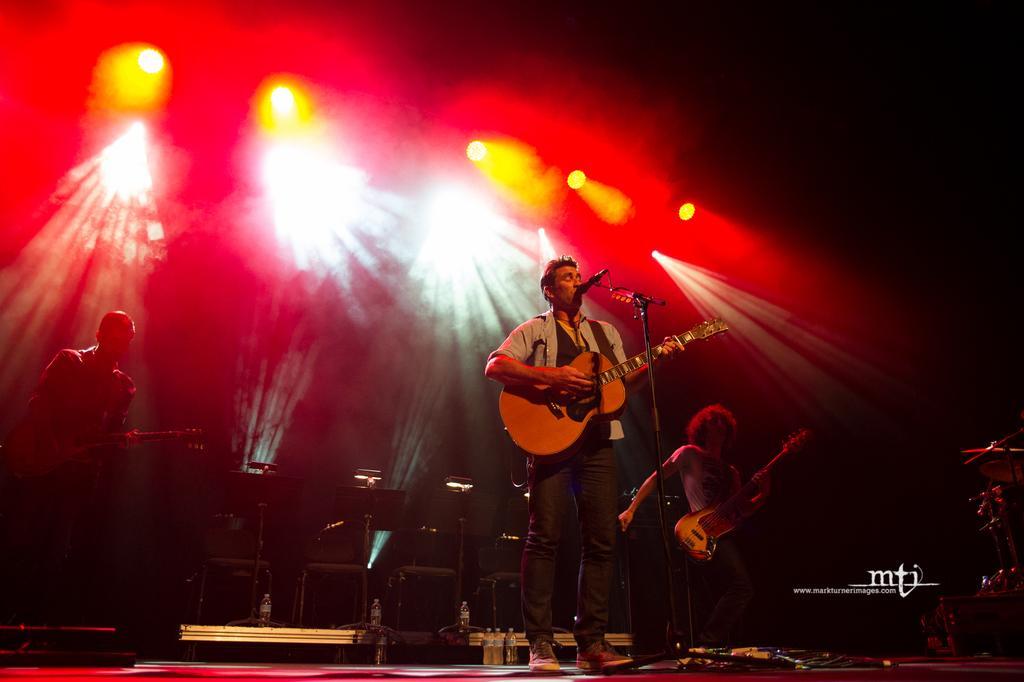Can you describe this image briefly? This image is clicked in a concert. There is a man standing in the front and playing guitar. In the background, there are lights in red color. At the bottom, there is a dais. To the right, there is a band. 